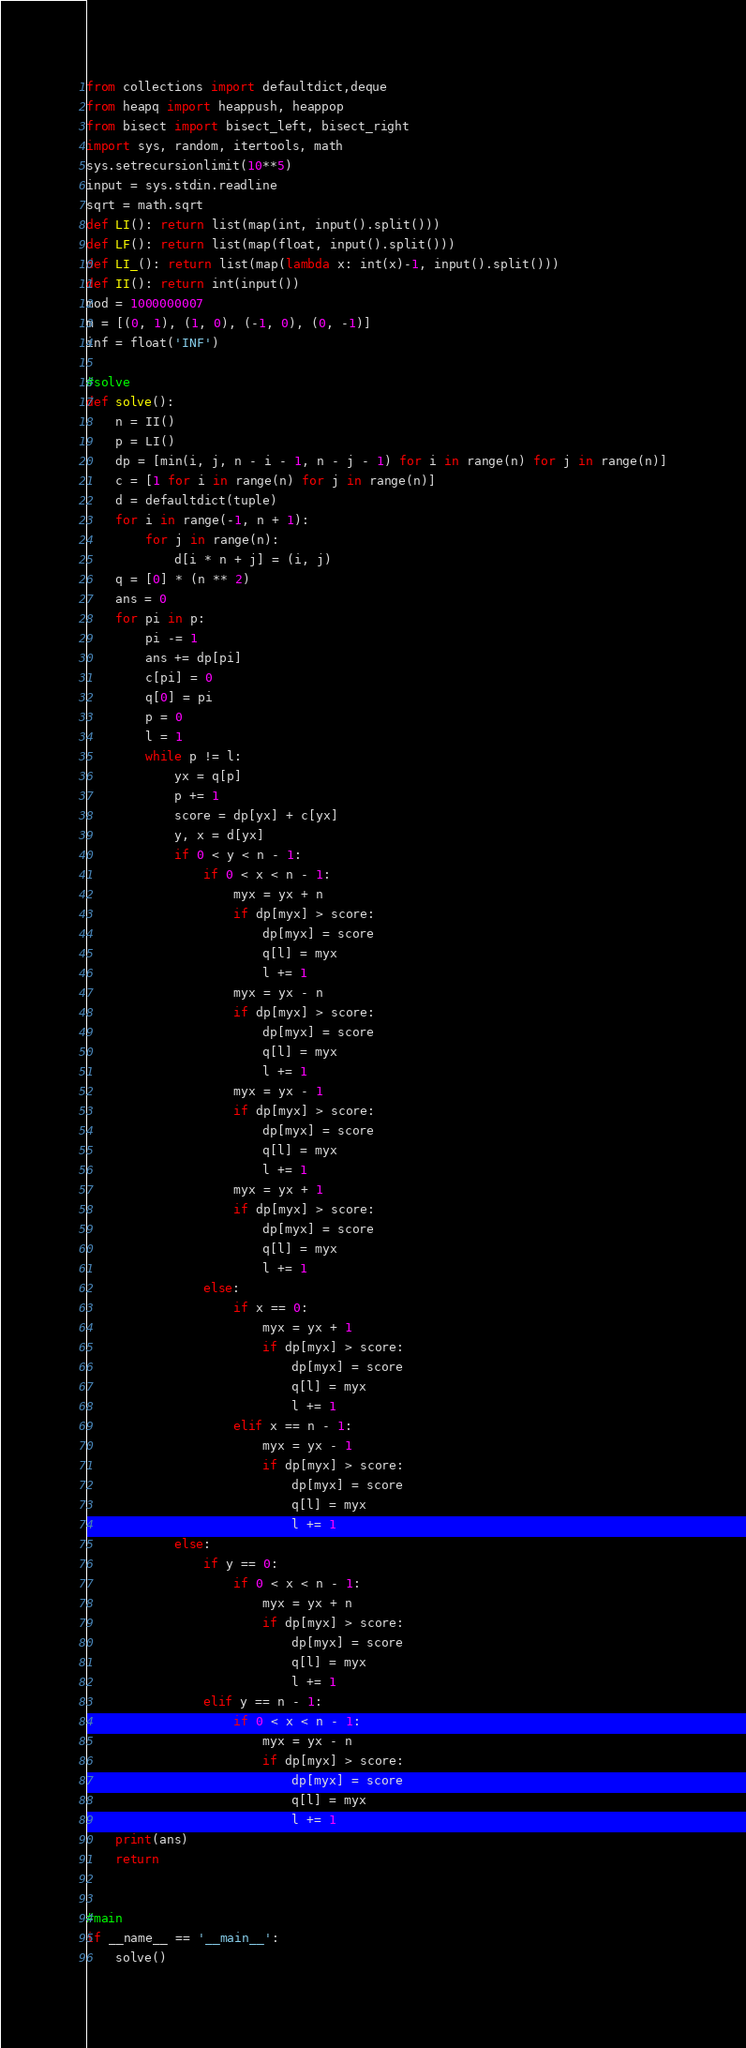<code> <loc_0><loc_0><loc_500><loc_500><_Cython_>from collections import defaultdict,deque
from heapq import heappush, heappop
from bisect import bisect_left, bisect_right
import sys, random, itertools, math
sys.setrecursionlimit(10**5)
input = sys.stdin.readline
sqrt = math.sqrt
def LI(): return list(map(int, input().split()))
def LF(): return list(map(float, input().split()))
def LI_(): return list(map(lambda x: int(x)-1, input().split()))
def II(): return int(input())
mod = 1000000007
m = [(0, 1), (1, 0), (-1, 0), (0, -1)]
inf = float('INF')

#solve
def solve():
    n = II()
    p = LI()
    dp = [min(i, j, n - i - 1, n - j - 1) for i in range(n) for j in range(n)]
    c = [1 for i in range(n) for j in range(n)]
    d = defaultdict(tuple)
    for i in range(-1, n + 1):
        for j in range(n):
            d[i * n + j] = (i, j)
    q = [0] * (n ** 2)
    ans = 0
    for pi in p:
        pi -= 1
        ans += dp[pi]
        c[pi] = 0
        q[0] = pi
        p = 0
        l = 1
        while p != l:
            yx = q[p]
            p += 1
            score = dp[yx] + c[yx]
            y, x = d[yx]
            if 0 < y < n - 1:
                if 0 < x < n - 1:
                    myx = yx + n
                    if dp[myx] > score:
                        dp[myx] = score
                        q[l] = myx
                        l += 1
                    myx = yx - n
                    if dp[myx] > score:
                        dp[myx] = score
                        q[l] = myx
                        l += 1
                    myx = yx - 1
                    if dp[myx] > score:
                        dp[myx] = score
                        q[l] = myx
                        l += 1
                    myx = yx + 1
                    if dp[myx] > score:
                        dp[myx] = score
                        q[l] = myx
                        l += 1
                else:
                    if x == 0:
                        myx = yx + 1
                        if dp[myx] > score:
                            dp[myx] = score
                            q[l] = myx
                            l += 1
                    elif x == n - 1:
                        myx = yx - 1
                        if dp[myx] > score:
                            dp[myx] = score
                            q[l] = myx
                            l += 1
            else:
                if y == 0:
                    if 0 < x < n - 1:
                        myx = yx + n
                        if dp[myx] > score:
                            dp[myx] = score
                            q[l] = myx
                            l += 1
                elif y == n - 1:
                    if 0 < x < n - 1:
                        myx = yx - n
                        if dp[myx] > score:
                            dp[myx] = score
                            q[l] = myx
                            l += 1
    print(ans)
    return


#main
if __name__ == '__main__':
    solve()
</code> 